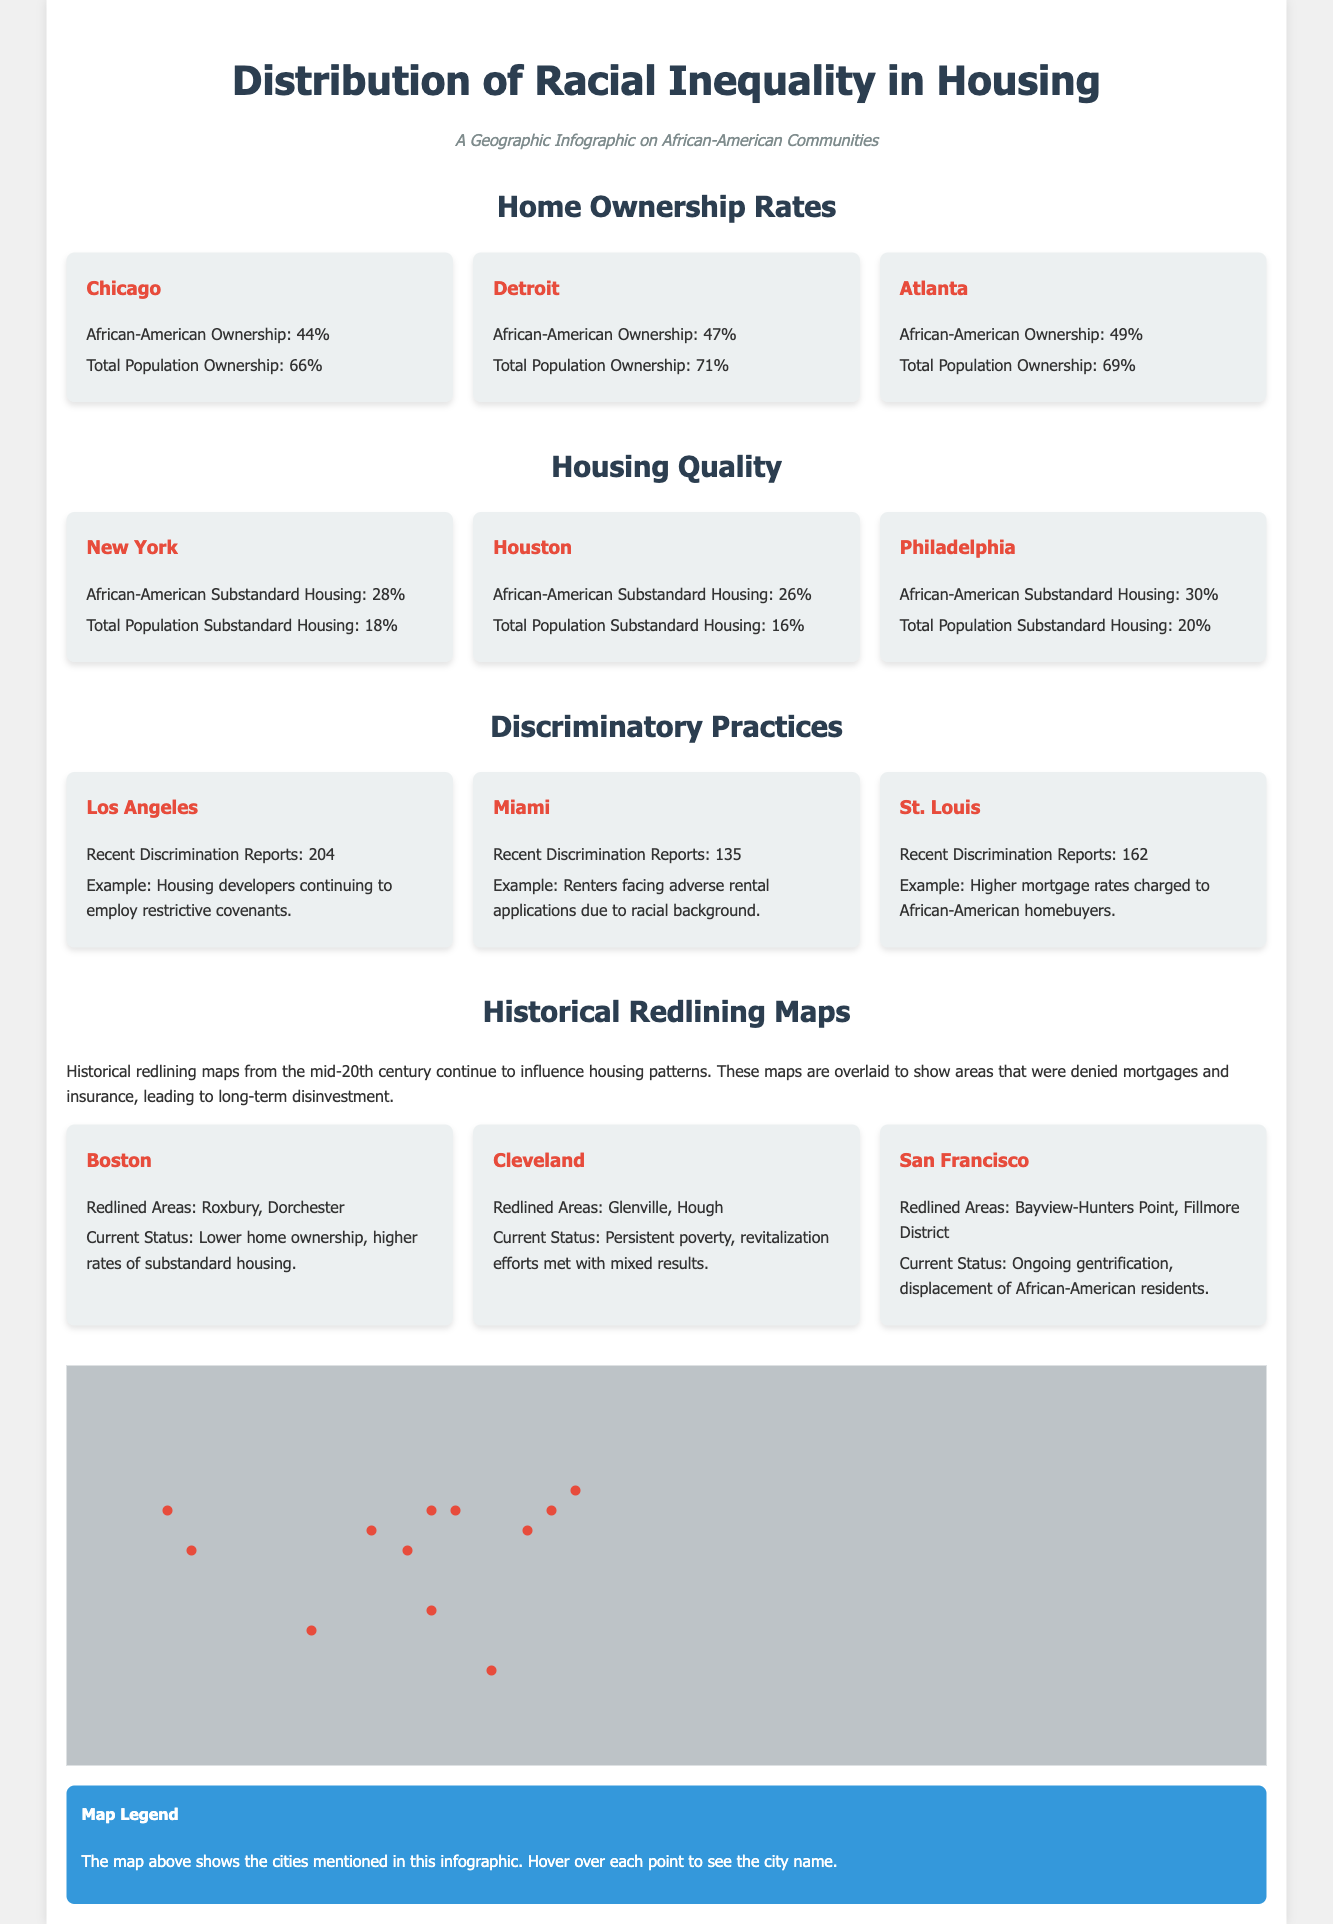What is the home ownership rate for African-Americans in Chicago? The home ownership rate for African-Americans in Chicago is specifically mentioned in the section on Home Ownership Rates, which states that it is 44%.
Answer: 44% What percentage of African-Americans in Philadelphia live in substandard housing? The document states that 30% of African-Americans in Philadelphia live in substandard housing, found in the Housing Quality section.
Answer: 30% How many discrimination reports were filed in Miami? There were 135 discrimination reports filed in Miami as detailed in the Discriminatory Practices section.
Answer: 135 Which city has the highest rate of African-American substandard housing, according to the infographic? The highest rate of substandard housing among African-Americans is in Philadelphia at 30%, compared with the others listed, requiring a comparison of the various rates mentioned in the document.
Answer: Philadelphia What redlined area is mentioned for Boston? The redlined areas for Boston are Roxbury and Dorchester, as stated in the Historical Redlining Maps section.
Answer: Roxbury, Dorchester In which city was the highest number of recent discrimination reports recorded? Los Angeles has the highest number of recent discrimination reports at 204, based on the Discriminatory Practices section.
Answer: Los Angeles What percentage of African-American home ownership is reported in Atlanta? The African-American home ownership rate in Atlanta is reported to be 49% in the Home Ownership Rates section.
Answer: 49% What does the infographic indicate about the influence of historical redlining maps? The document states that historical redlining maps continue to influence housing patterns, indicating their long-term impact, found in the Historical Redlining Maps section.
Answer: Influence housing patterns Which city is associated with ongoing gentrification and displacement of African-American residents? San Francisco is mentioned to have ongoing gentrification and displacement of African-American residents in the Historical Redlining Maps section.
Answer: San Francisco 